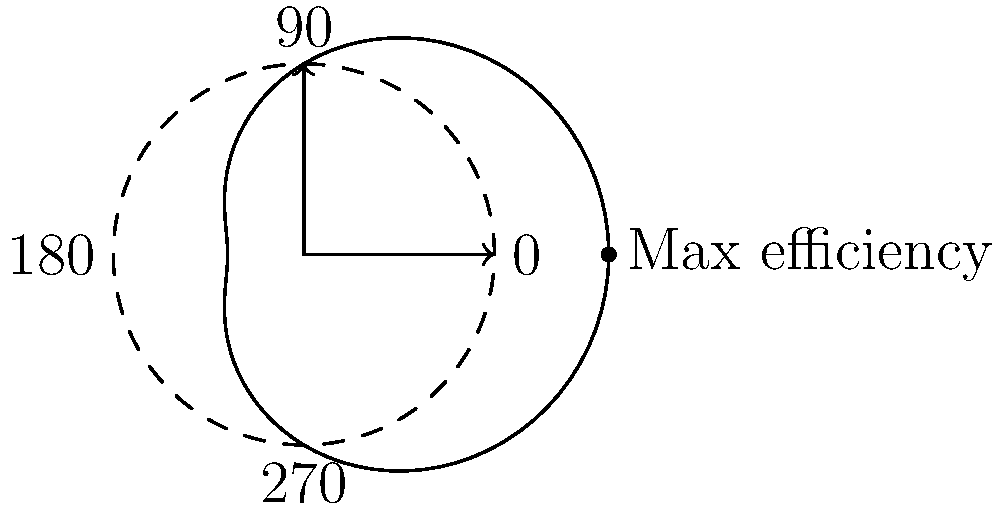In optimizing the angle of a takedown for maximum efficiency, the polar graph represents the relationship between the angle of attack and the effectiveness of the takedown. The distance from the center indicates the level of efficiency. Based on the graph, at which angle (in degrees) is the takedown most efficient? To determine the angle of maximum efficiency for the takedown, we need to analyze the polar graph:

1. The graph shows a cardioid-like shape, which is typical for directional efficiency patterns.
2. The efficiency is represented by the distance from the center of the graph.
3. The maximum distance from the center occurs at the rightmost point of the graph.
4. This point aligns with the positive x-axis, which corresponds to 0° (or 360°) in polar coordinates.
5. In MMA terms, this suggests that a straight-forward takedown (directly in front of the fighter) is most efficient.
6. The 0° angle typically represents an attack that exploits an opponent's frontal vulnerability, maximizing the use of the attacker's forward momentum.
7. This aligns with common MMA strategies where direct, explosive forward movements often yield the most successful takedowns.

Therefore, based on the given polar graph, the takedown is most efficient at a 0° angle.
Answer: 0° 